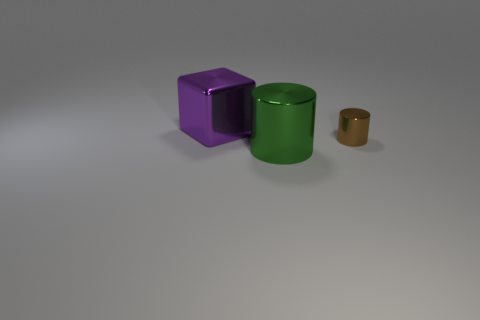Add 1 large purple objects. How many objects exist? 4 Add 1 tiny cylinders. How many tiny cylinders are left? 2 Add 1 green metal objects. How many green metal objects exist? 2 Subtract 0 gray balls. How many objects are left? 3 Subtract all cubes. How many objects are left? 2 Subtract all brown cubes. Subtract all red cylinders. How many cubes are left? 1 Subtract all big cubes. Subtract all big green shiny objects. How many objects are left? 1 